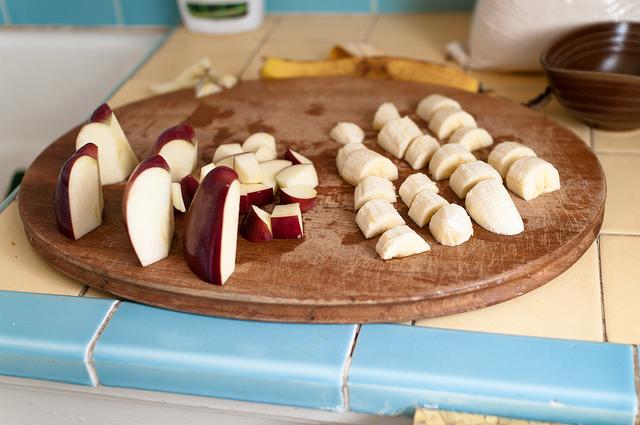Is this a healthy meal?
Be succinct. Yes. What is the fruit on?
Answer briefly. Cutting board. What color are the tiles?
Give a very brief answer. Tan. What fruit is this?
Short answer required. Apple and banana. 